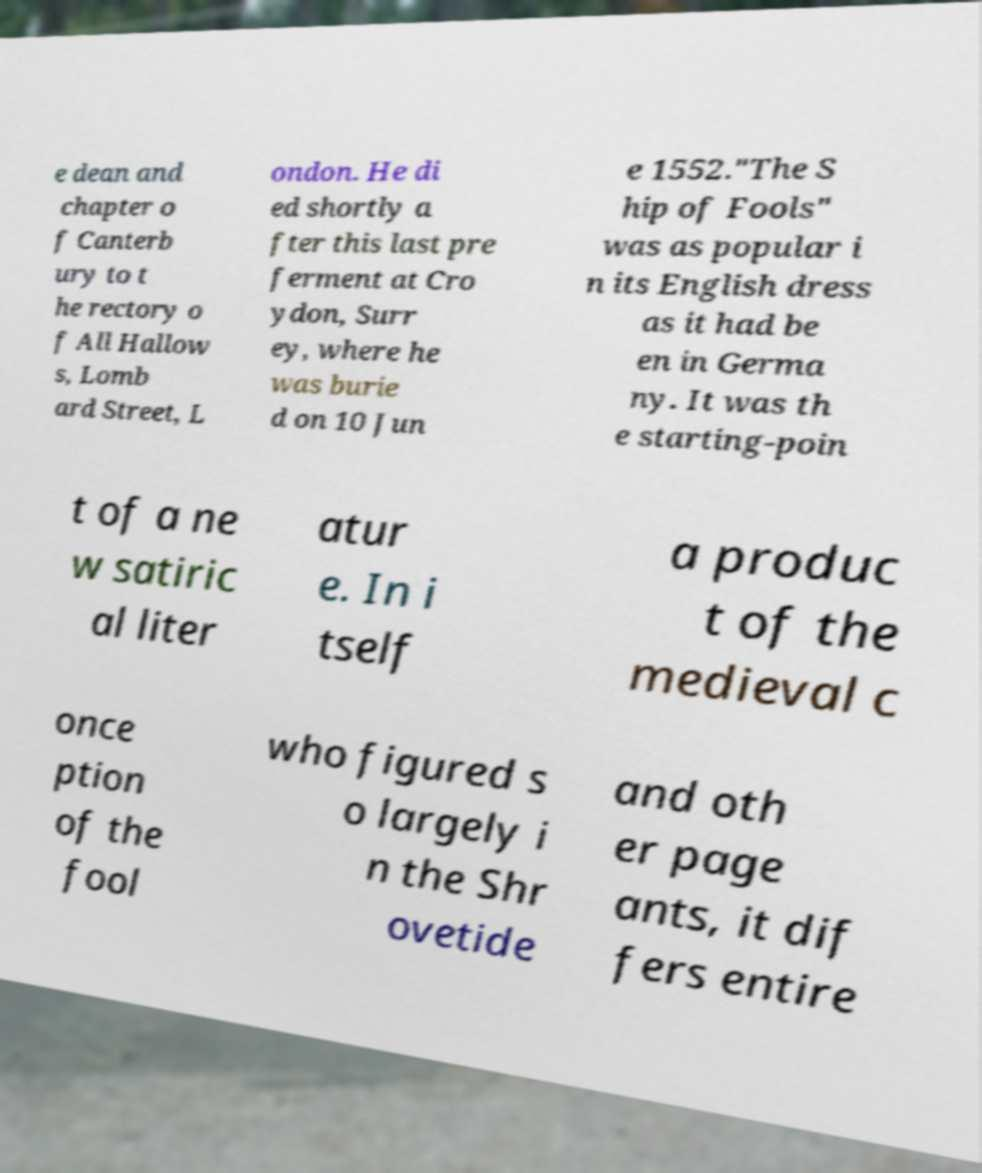For documentation purposes, I need the text within this image transcribed. Could you provide that? e dean and chapter o f Canterb ury to t he rectory o f All Hallow s, Lomb ard Street, L ondon. He di ed shortly a fter this last pre ferment at Cro ydon, Surr ey, where he was burie d on 10 Jun e 1552."The S hip of Fools" was as popular i n its English dress as it had be en in Germa ny. It was th e starting-poin t of a ne w satiric al liter atur e. In i tself a produc t of the medieval c once ption of the fool who figured s o largely i n the Shr ovetide and oth er page ants, it dif fers entire 